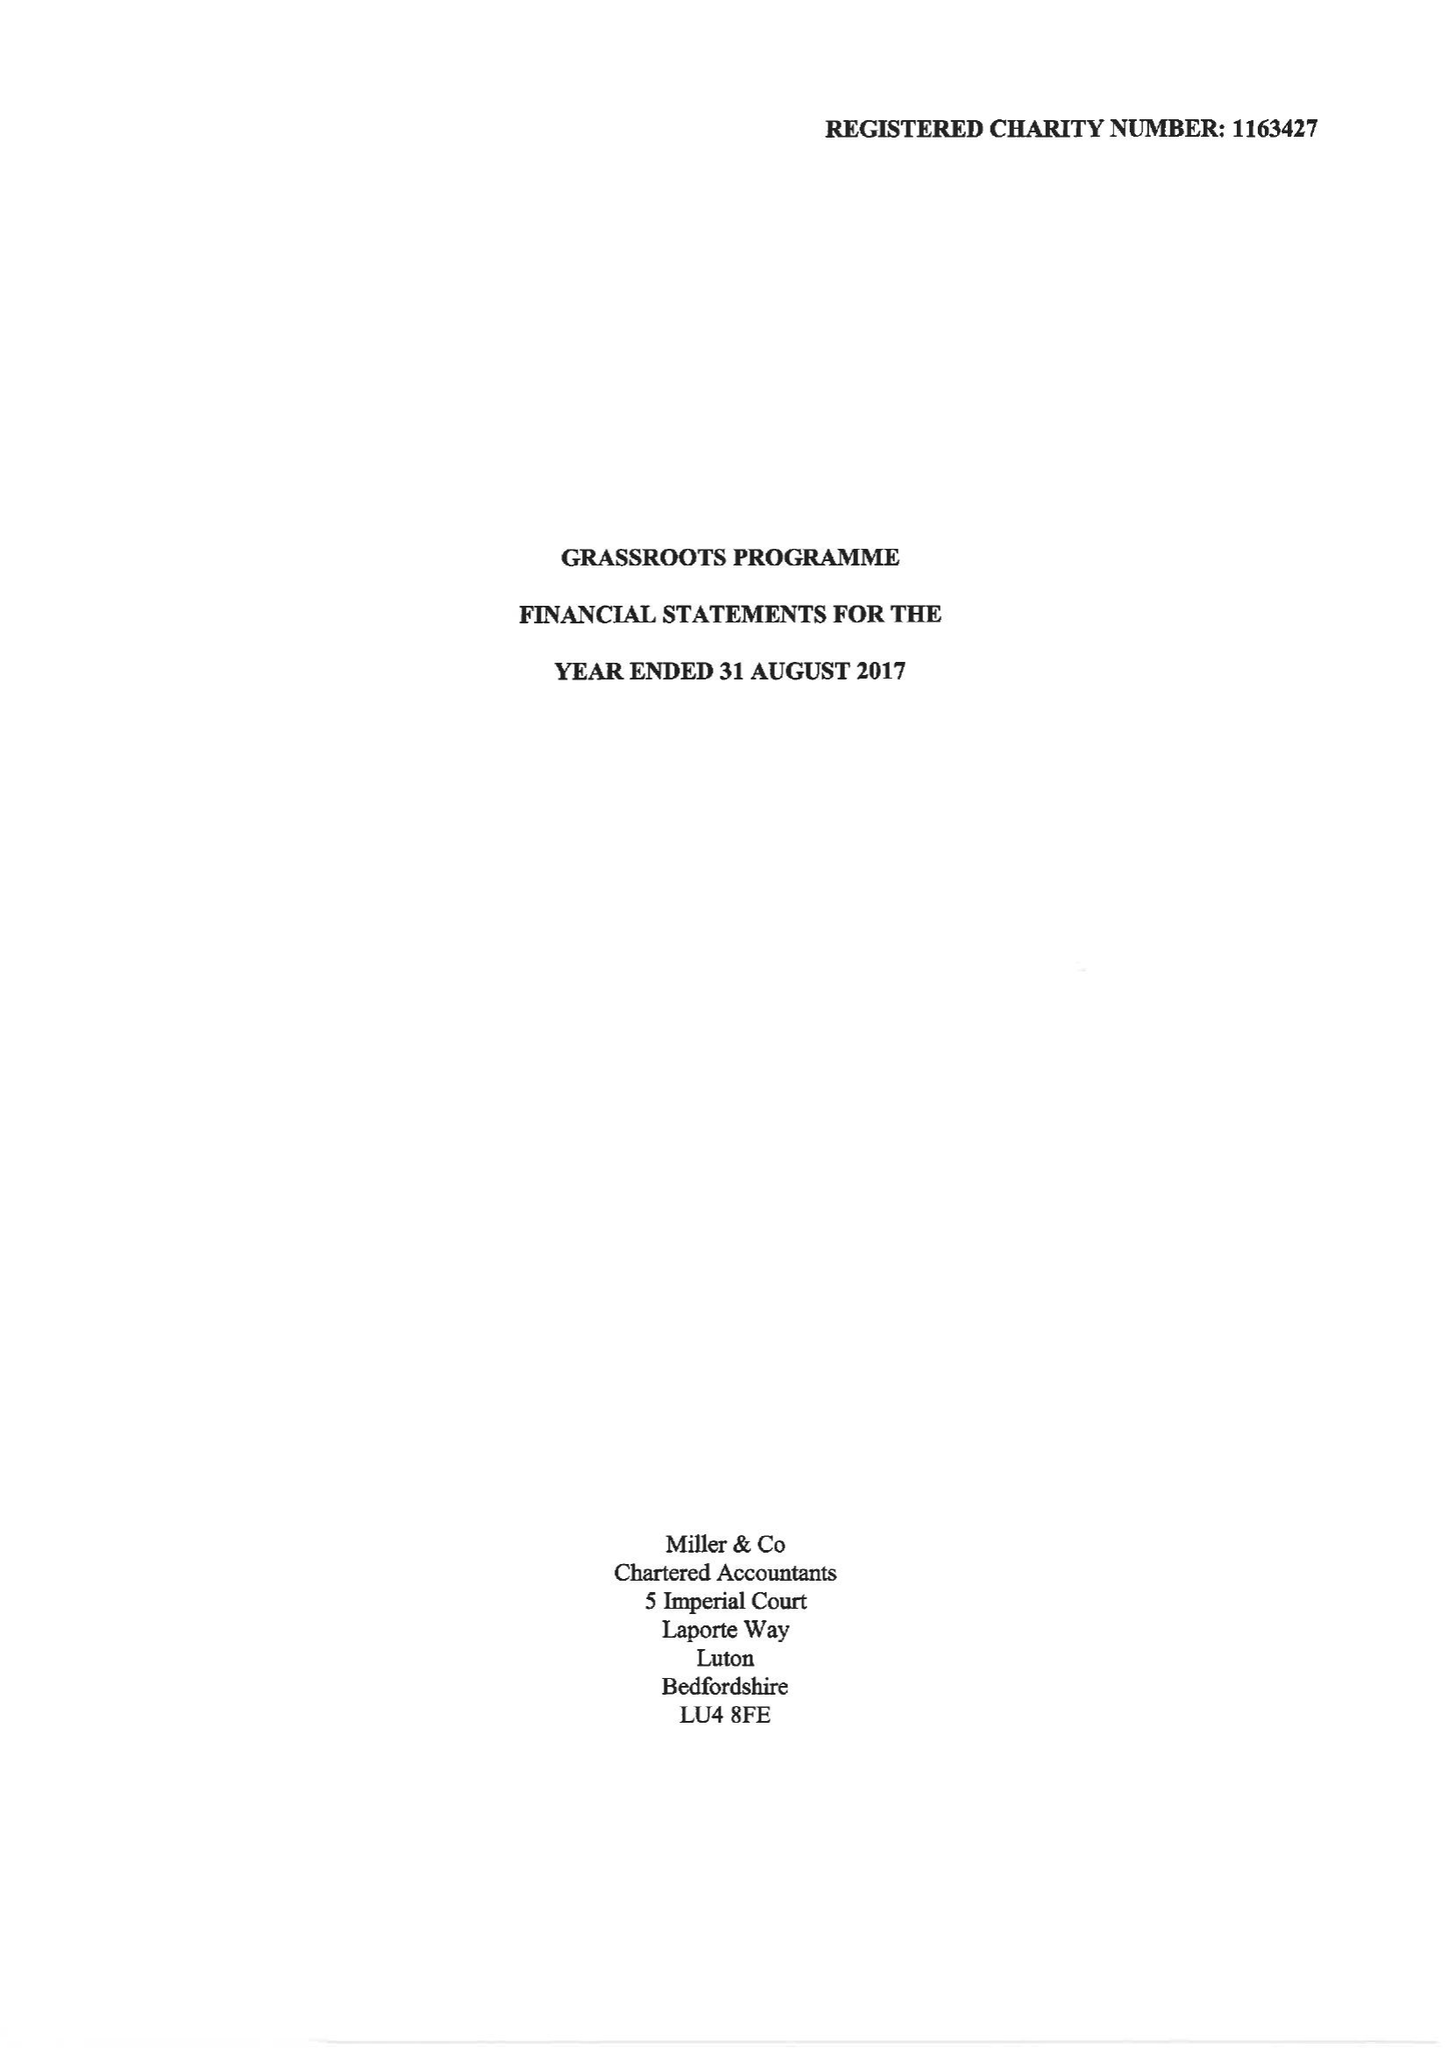What is the value for the report_date?
Answer the question using a single word or phrase. 2017-08-31 